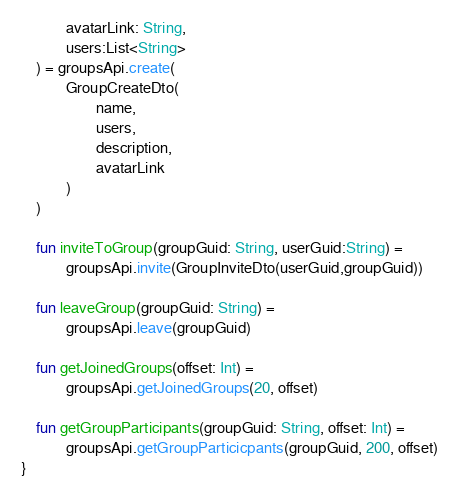<code> <loc_0><loc_0><loc_500><loc_500><_Kotlin_>            avatarLink: String,
            users:List<String>
    ) = groupsApi.create(
            GroupCreateDto(
                    name,
                    users,
                    description,
                    avatarLink
            )
    )

    fun inviteToGroup(groupGuid: String, userGuid:String) =
            groupsApi.invite(GroupInviteDto(userGuid,groupGuid))

    fun leaveGroup(groupGuid: String) =
            groupsApi.leave(groupGuid)

    fun getJoinedGroups(offset: Int) =
            groupsApi.getJoinedGroups(20, offset)

    fun getGroupParticipants(groupGuid: String, offset: Int) =
            groupsApi.getGroupParticicpants(groupGuid, 200, offset)
}</code> 